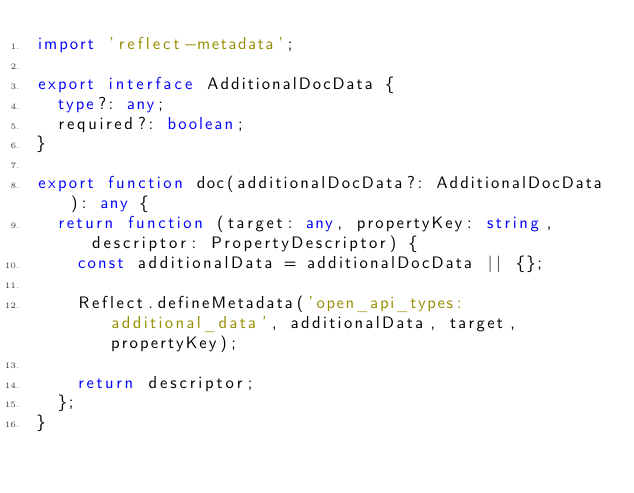<code> <loc_0><loc_0><loc_500><loc_500><_TypeScript_>import 'reflect-metadata';

export interface AdditionalDocData {
  type?: any;
  required?: boolean;
}

export function doc(additionalDocData?: AdditionalDocData): any {
  return function (target: any, propertyKey: string, descriptor: PropertyDescriptor) {
    const additionalData = additionalDocData || {};

    Reflect.defineMetadata('open_api_types:additional_data', additionalData, target, propertyKey);

    return descriptor;
  };
}
</code> 